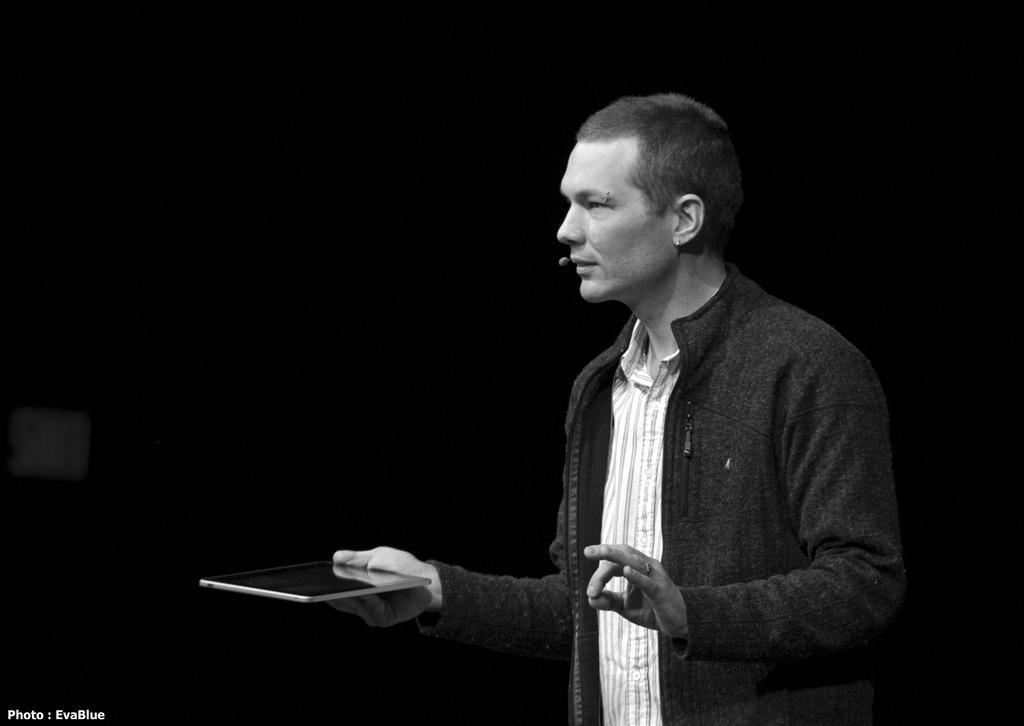In one or two sentences, can you explain what this image depicts? In this Image I see a man who is standing and holding an electronic device. 